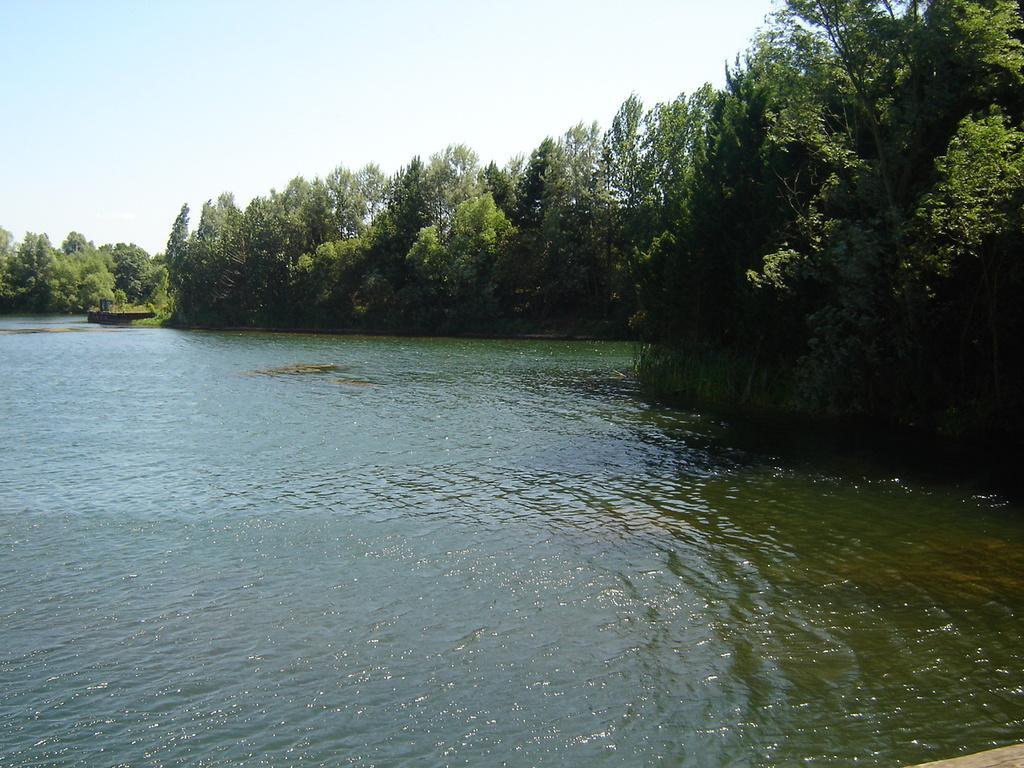How would you summarize this image in a sentence or two? In this image I can see water and number of trees in the front. I can also see the sky in the background. 